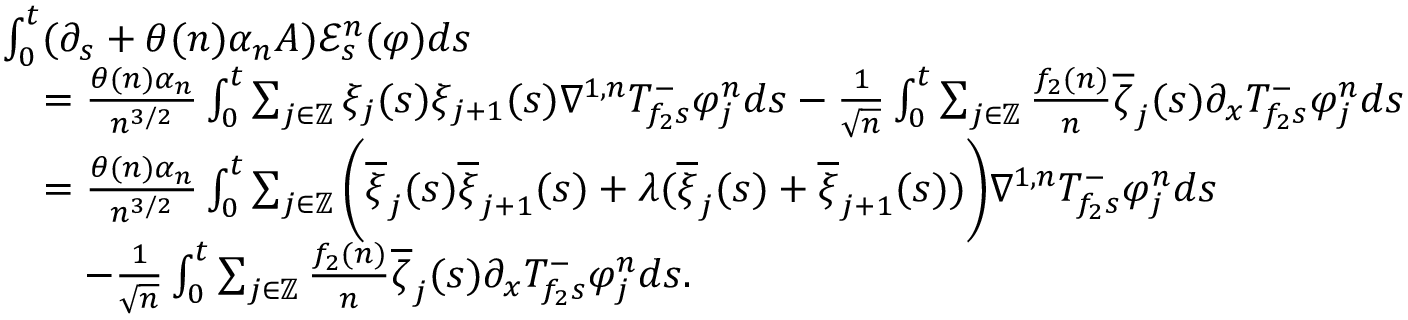<formula> <loc_0><loc_0><loc_500><loc_500>\begin{array} { r l } & { \int _ { 0 } ^ { t } ( \partial _ { s } + \theta ( n ) \alpha _ { n } A ) \mathcal { E } _ { s } ^ { n } ( \varphi ) d s } \\ & { \quad = \frac { \theta ( n ) \alpha _ { n } } { n ^ { 3 / 2 } } \int _ { 0 } ^ { t } \sum _ { j \in \mathbb { Z } } \xi _ { j } ( s ) \xi _ { j + 1 } ( s ) \nabla ^ { 1 , n } T _ { f _ { 2 } s } ^ { - } \varphi _ { j } ^ { n } d s - \frac { 1 } { \sqrt { n } } \int _ { 0 } ^ { t } \sum _ { j \in \mathbb { Z } } \frac { f _ { 2 } ( n ) } { n } \overline { \zeta } _ { j } ( s ) \partial _ { x } T _ { f _ { 2 } s } ^ { - } \varphi _ { j } ^ { n } d s } \\ & { \quad = \frac { \theta ( n ) \alpha _ { n } } { n ^ { 3 / 2 } } \int _ { 0 } ^ { t } \sum _ { j \in \mathbb { Z } } \left ( \overline { \xi } _ { j } ( s ) \overline { \xi } _ { j + 1 } ( s ) + \lambda ( \overline { \xi } _ { j } ( s ) + \overline { \xi } _ { j + 1 } ( s ) ) \right ) \nabla ^ { 1 , n } T _ { f _ { 2 } s } ^ { - } \varphi _ { j } ^ { n } d s } \\ & { \quad - \frac { 1 } { \sqrt { n } } \int _ { 0 } ^ { t } \sum _ { j \in \mathbb { Z } } \frac { f _ { 2 } ( n ) } { n } \overline { \zeta } _ { j } ( s ) \partial _ { x } T _ { f _ { 2 } s } ^ { - } \varphi _ { j } ^ { n } d s . } \end{array}</formula> 